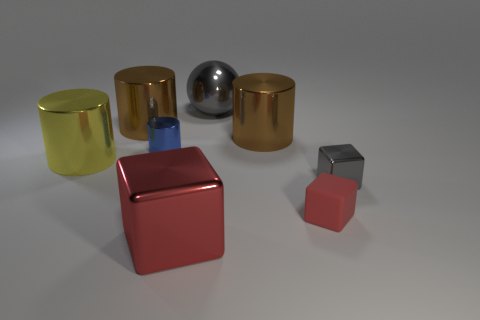There is a block that is the same color as the ball; what size is it?
Ensure brevity in your answer.  Small. How many large metallic things have the same color as the small metallic cube?
Make the answer very short. 1. What is the tiny cylinder made of?
Offer a very short reply. Metal. Is there a purple rubber cube that has the same size as the yellow cylinder?
Keep it short and to the point. No. What material is the cube that is the same size as the gray shiny sphere?
Your answer should be very brief. Metal. What number of tiny brown cylinders are there?
Offer a terse response. 0. How big is the metallic block to the left of the small red rubber object?
Offer a very short reply. Large. Are there the same number of blue shiny cylinders behind the tiny rubber block and green spheres?
Ensure brevity in your answer.  No. Is there a large cyan shiny thing that has the same shape as the red matte object?
Your answer should be very brief. No. The thing that is to the right of the big gray metal ball and behind the tiny gray shiny cube has what shape?
Give a very brief answer. Cylinder. 